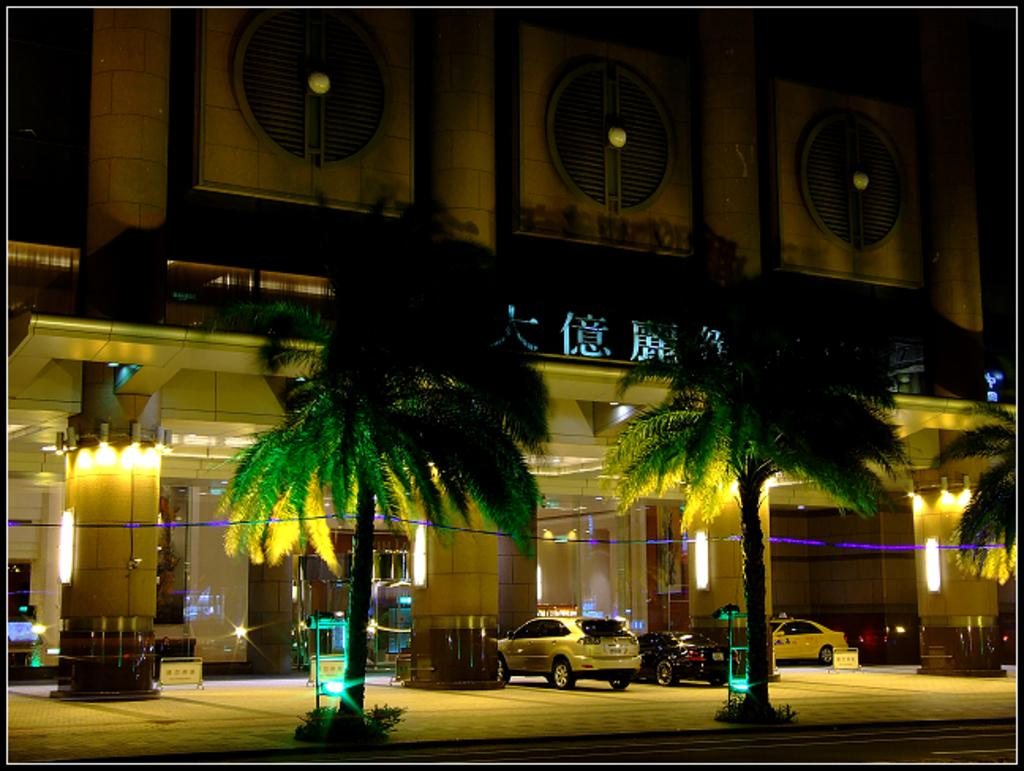What types of objects can be seen in the image? There are vehicles, trees, lights on the ceiling, an LED board, a building, pillars, and other objects on the ground in the image. Can you describe the setting of the image? The image features a building with pillars, an LED board, and trees, as well as vehicles and other objects on the ground. What might be used for illumination in the image? The lights on the ceiling can be used for illumination in the image. How many types of objects are on the ground in the image? There are at least two types of objects on the ground: vehicles and other objects. What type of jewel can be seen falling from the sky in the image? There is no jewel or falling object present in the image. How does the building crush the vehicles in the image? The building does not crush the vehicles in the image; they are not interacting with each other. 